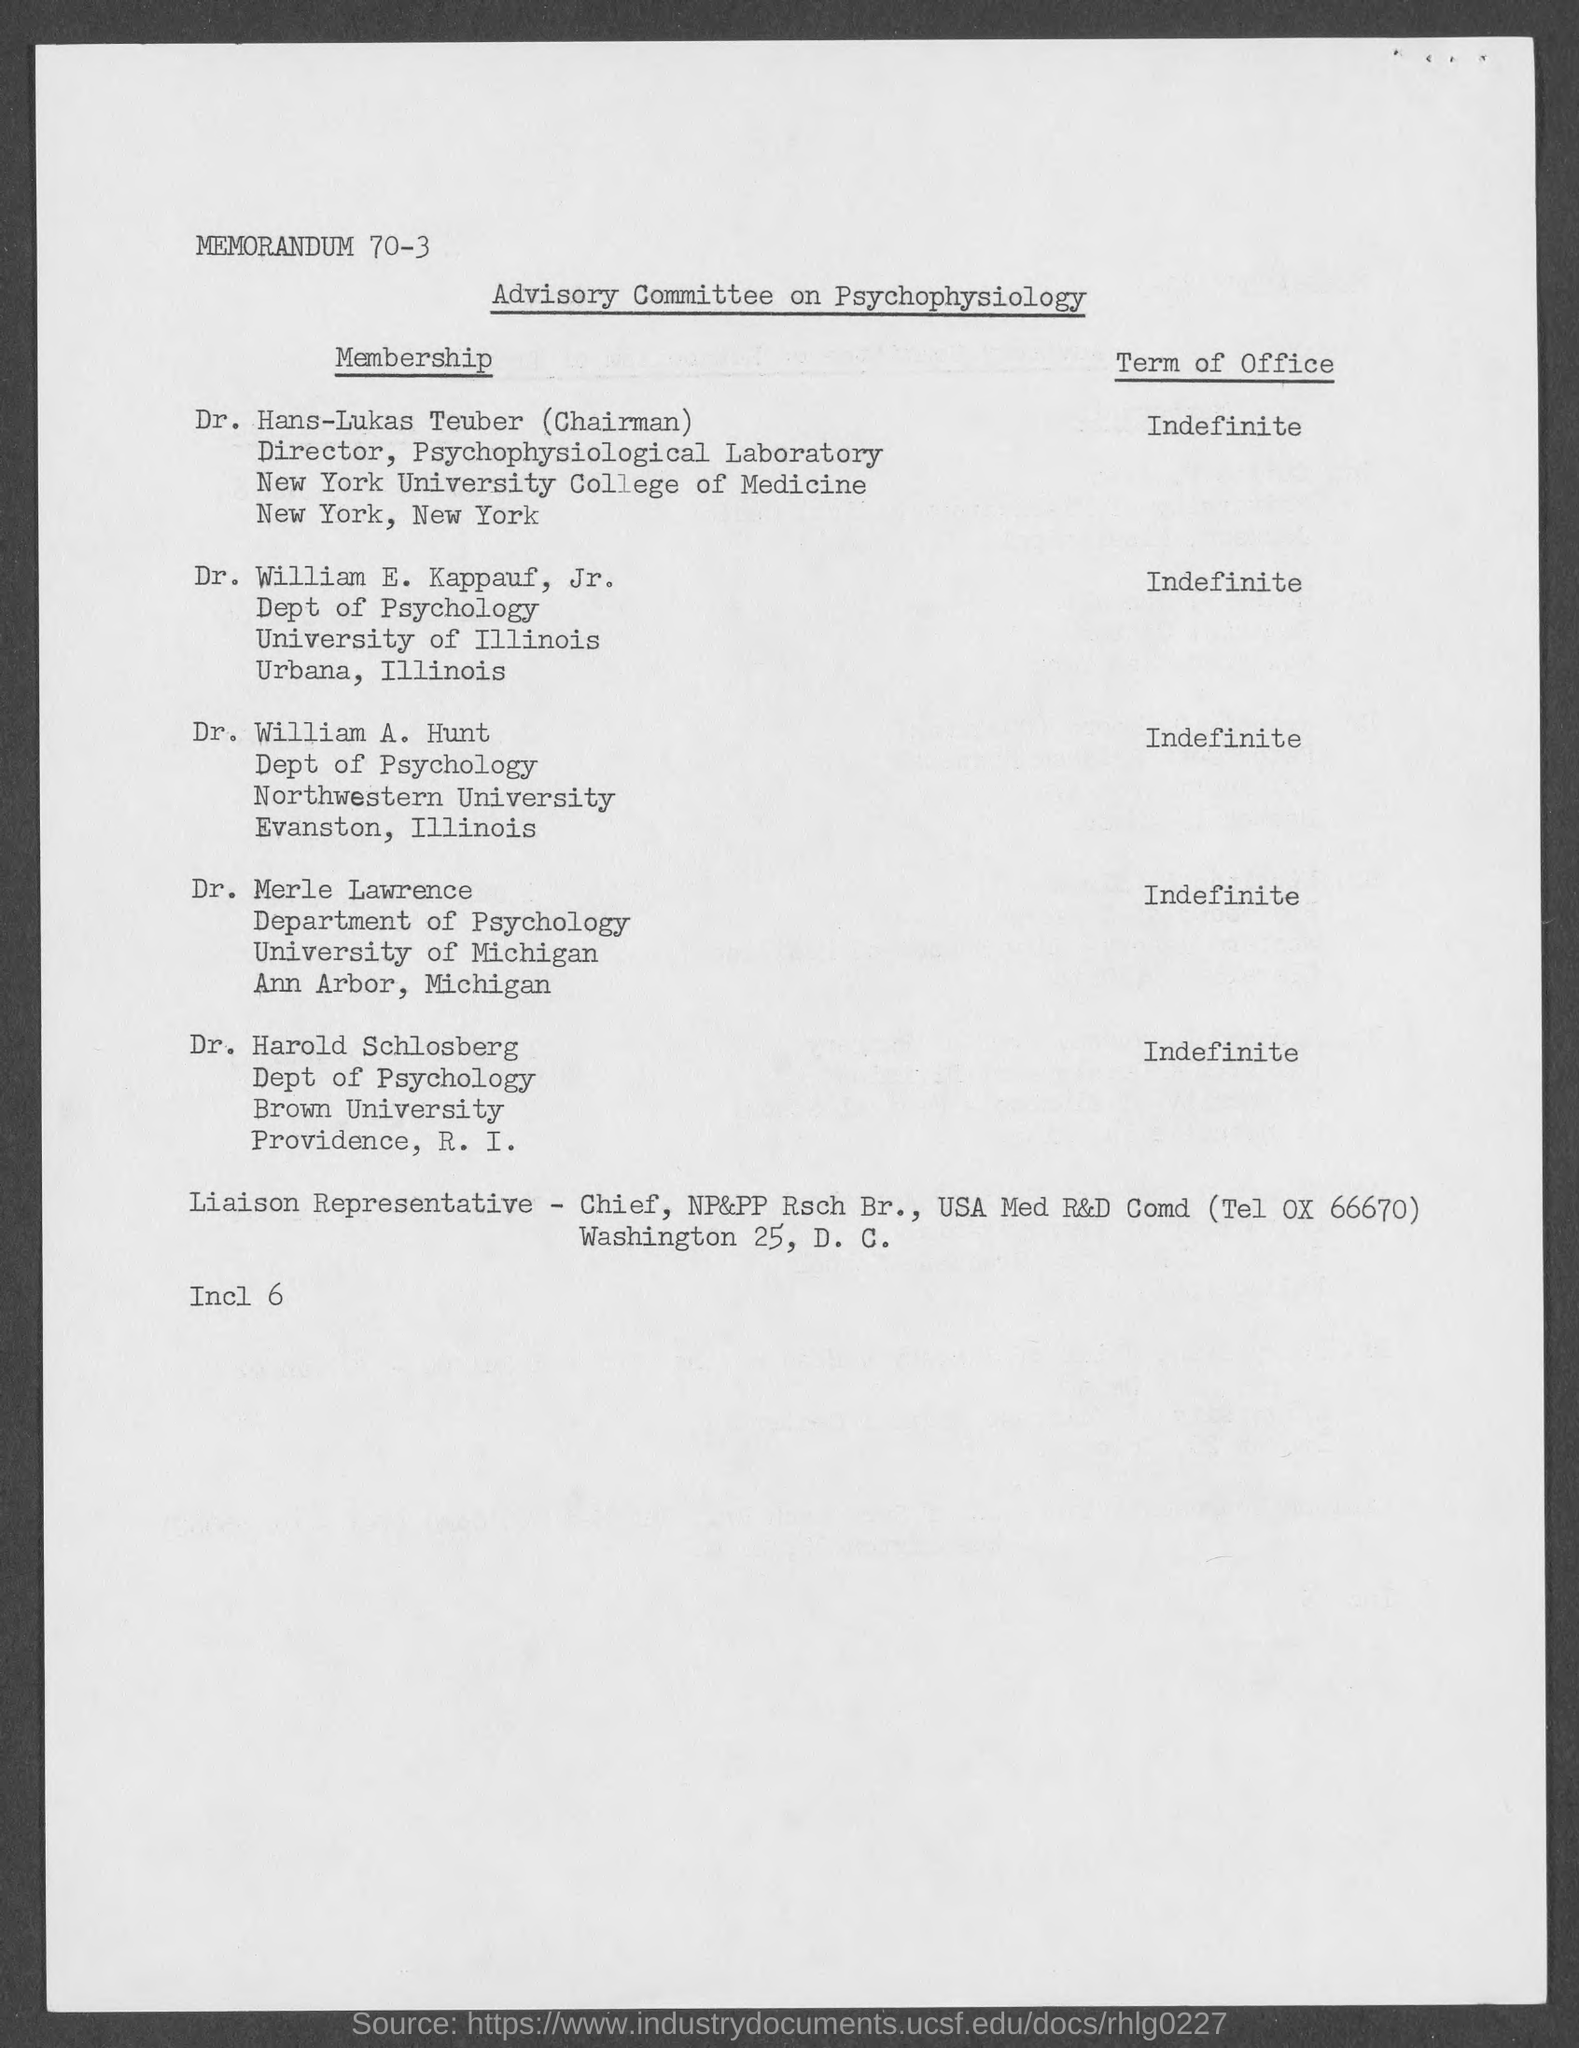What is the name of the Committee?
Your answer should be compact. ADVISORY COMMITTEE ON PSYCHOPHYSIOLOGY. 